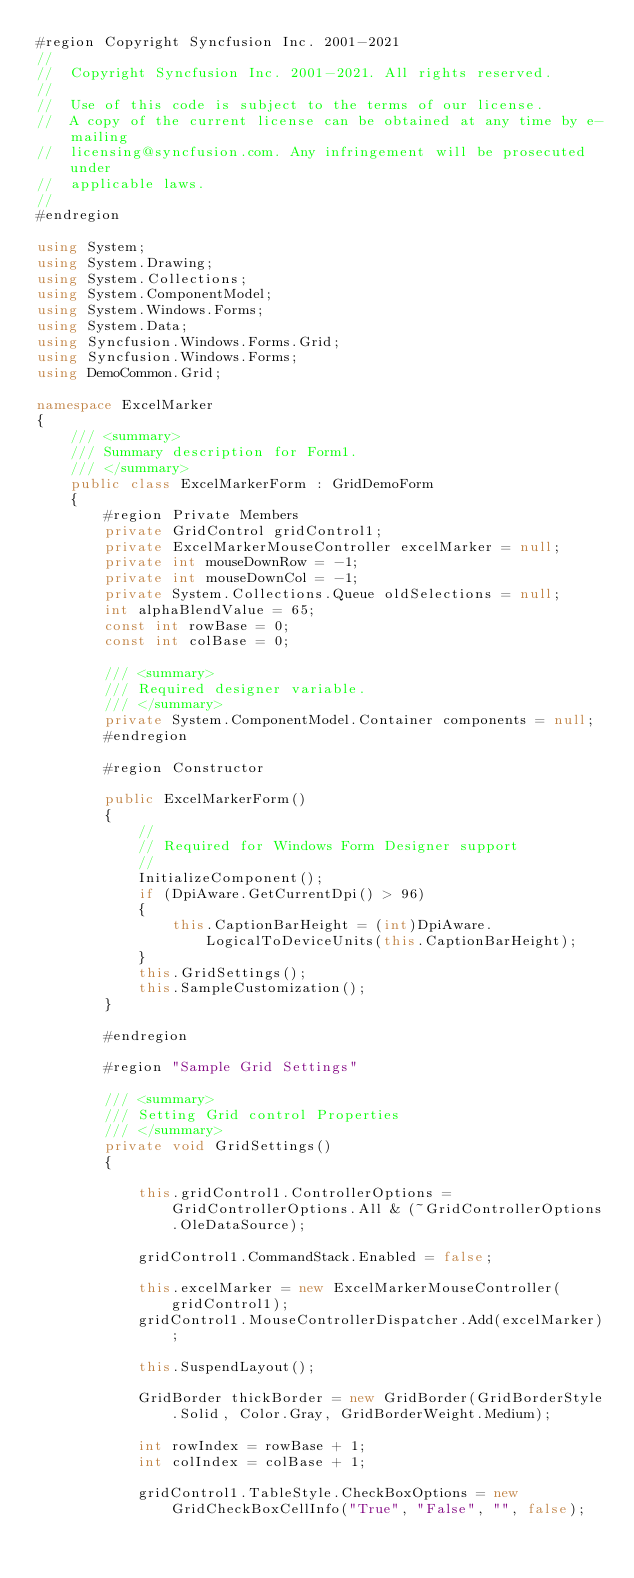<code> <loc_0><loc_0><loc_500><loc_500><_C#_>#region Copyright Syncfusion Inc. 2001-2021
//
//  Copyright Syncfusion Inc. 2001-2021. All rights reserved.
//
//  Use of this code is subject to the terms of our license.
//  A copy of the current license can be obtained at any time by e-mailing
//  licensing@syncfusion.com. Any infringement will be prosecuted under
//  applicable laws. 
//
#endregion

using System;
using System.Drawing;
using System.Collections;
using System.ComponentModel;
using System.Windows.Forms;
using System.Data;
using Syncfusion.Windows.Forms.Grid;
using Syncfusion.Windows.Forms;
using DemoCommon.Grid;

namespace ExcelMarker
{
	/// <summary>
	/// Summary description for Form1.
	/// </summary>
	public class ExcelMarkerForm : GridDemoForm
    {
        #region Private Members
        private GridControl gridControl1;
		private ExcelMarkerMouseController excelMarker = null;
		private int mouseDownRow = -1;
		private int mouseDownCol = -1;
		private System.Collections.Queue oldSelections = null;
		int alphaBlendValue = 65;
		const int rowBase = 0;
		const int colBase = 0;

		/// <summary>
		/// Required designer variable.
		/// </summary>
		private System.ComponentModel.Container components = null;
        #endregion

        #region Constructor

        public ExcelMarkerForm()
		{
			//
			// Required for Windows Form Designer support
			//
			InitializeComponent();
            if (DpiAware.GetCurrentDpi() > 96)
            {
                this.CaptionBarHeight = (int)DpiAware.LogicalToDeviceUnits(this.CaptionBarHeight);
            }
            this.GridSettings();
            this.SampleCustomization();
        }

        #endregion

        #region "Sample Grid Settings"

        /// <summary>
        /// Setting Grid control Properties
        /// </summary>
        private void GridSettings()
        {

            this.gridControl1.ControllerOptions = GridControllerOptions.All & (~GridControllerOptions.OleDataSource);

            gridControl1.CommandStack.Enabled = false;

            this.excelMarker = new ExcelMarkerMouseController(gridControl1);
            gridControl1.MouseControllerDispatcher.Add(excelMarker);

            this.SuspendLayout();

            GridBorder thickBorder = new GridBorder(GridBorderStyle.Solid, Color.Gray, GridBorderWeight.Medium);

            int rowIndex = rowBase + 1;
            int colIndex = colBase + 1;

            gridControl1.TableStyle.CheckBoxOptions = new GridCheckBoxCellInfo("True", "False", "", false);
</code> 